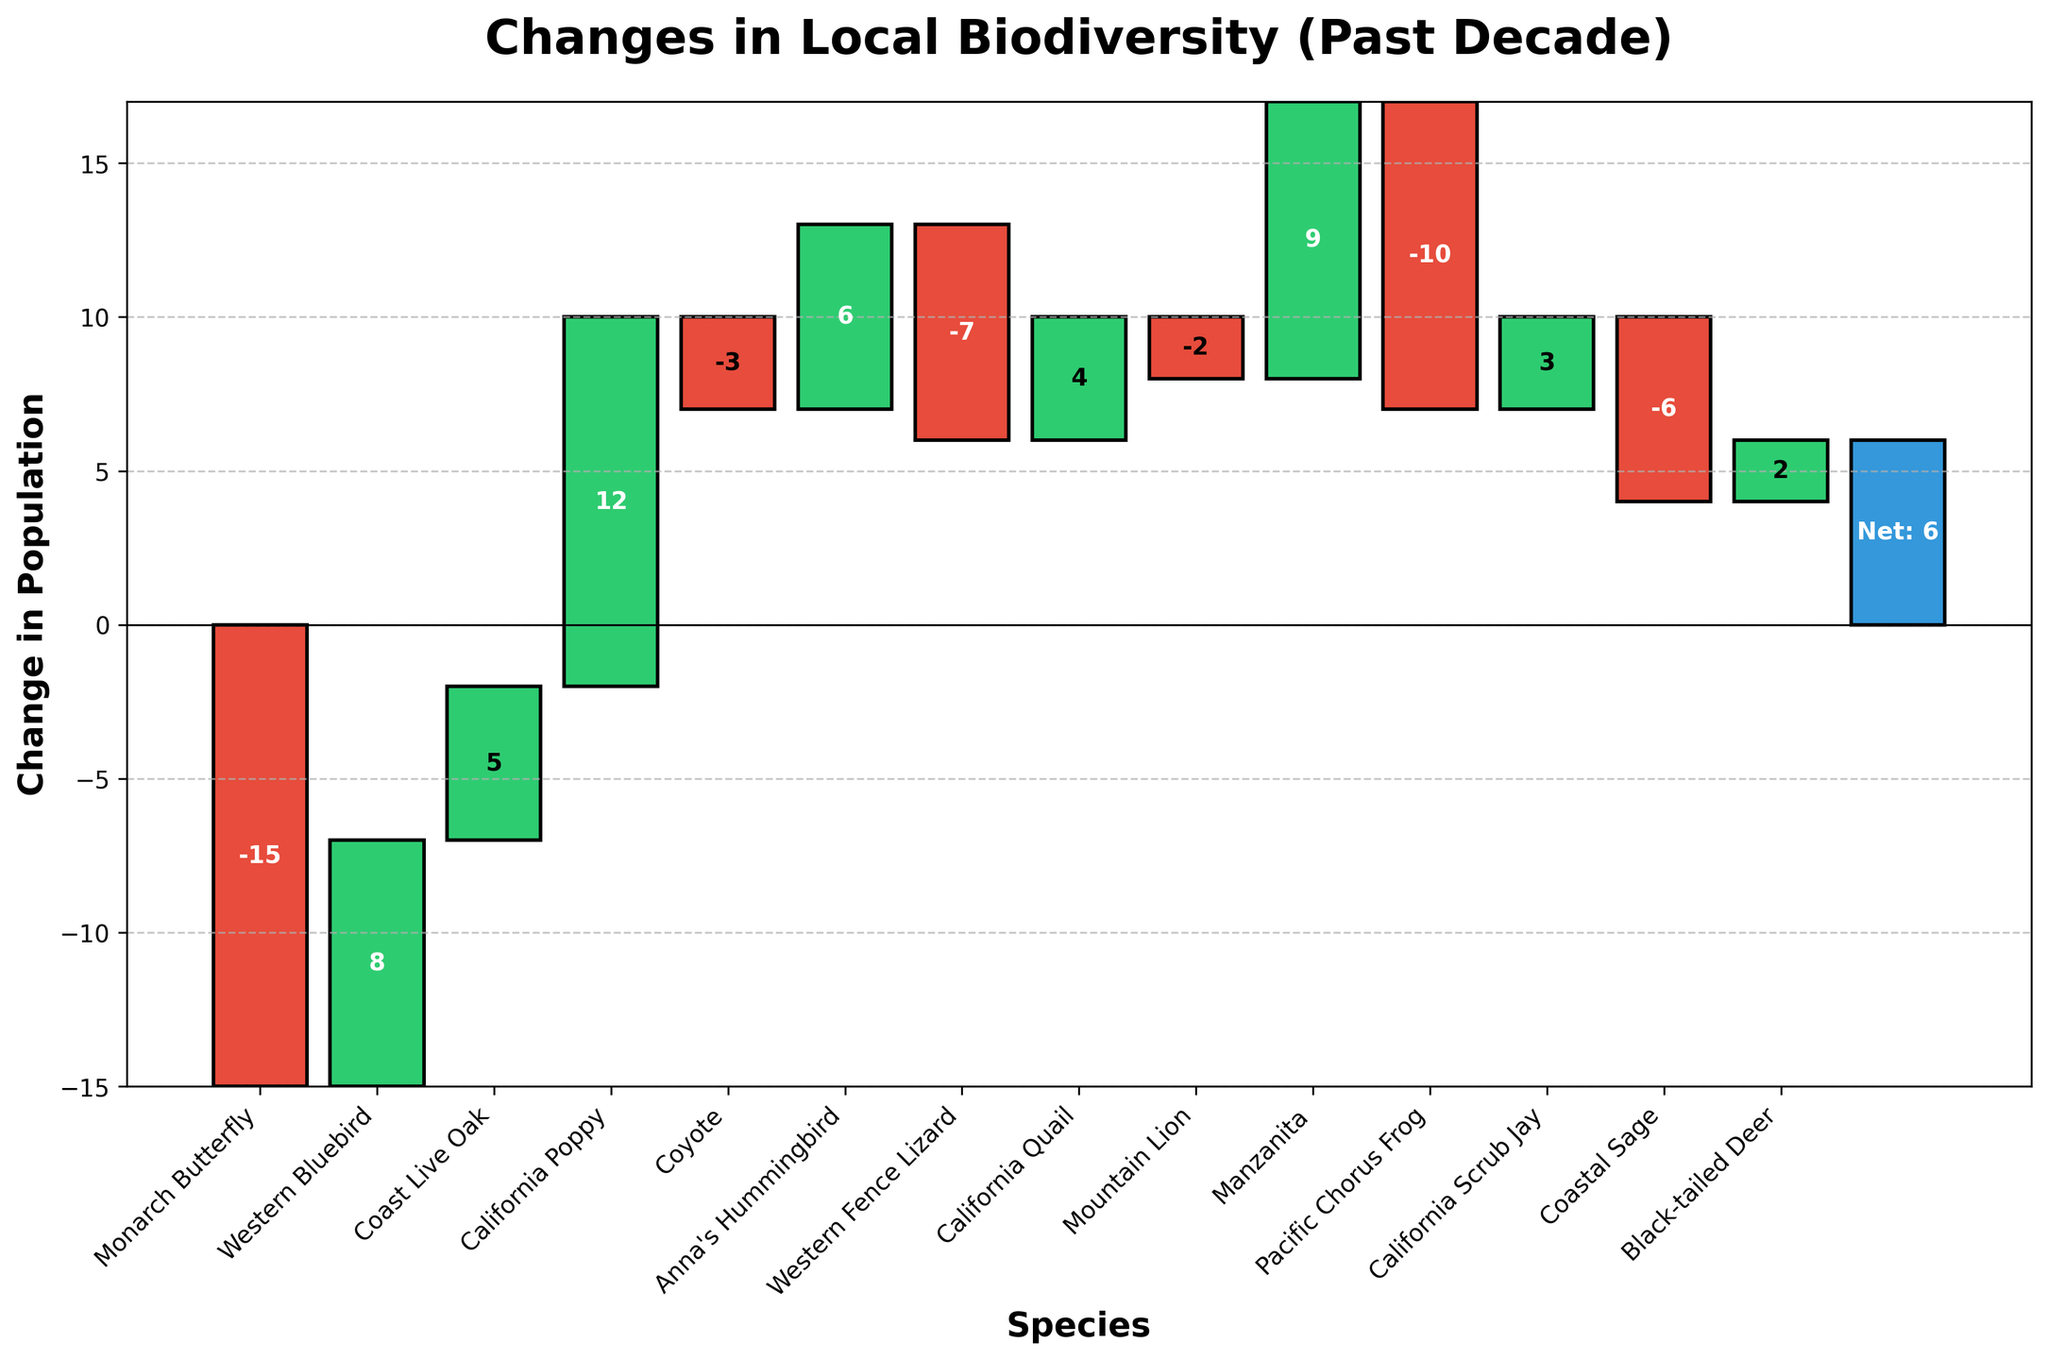What's the overall title of the chart? The overall title of the chart is found at the top and describes the main focus of the chart.
Answer: Changes in Local Biodiversity (Past Decade) How many species showed an increase in population? To determine the number of species that showed an increase in population, count the bars with colors that indicate a positive change.
Answer: 8 Which species had the greatest population decrease? Identify the species with the longest negative bar.
Answer: Monarch Butterfly What is the net change in the total population? The net change is represented by the final bar at the end; it's the cumulative result of all the species' population changes.
Answer: 16 Which species had a higher increase: Manzanita or California Poppy? Compare the lengths of the positive bars for Manzanita and California Poppy.
Answer: California Poppy What is the combined change for the Monarch Butterfly and Western Fence Lizard? Sum the changes for the Monarch Butterfly (-15) and Western Fence Lizard (-7).
Answer: -22 Which had a greater population decrease, the Coyote or the Pacific Chorus Frog? Compare the negative changes for both the Coyote and Pacific Chorus Frog.
Answer: Pacific Chorus Frog How many species experienced a decrease in population? Count the number of species with bars below the zero line.
Answer: 6 What is the cumulative change in population after the California Poppy? Perform cumulative sum up to and including the change for the California Poppy. The cumulative changes are (-15, -7, -2, 10) for Monarch Butterfly, Western Bluebird, Coast Live Oak, and California Poppy respectively.
Answer: 10 What is the difference in population change between Anna's Hummingbird and the Mountain Lion? Subtract the change for Mountain Lion from the change for Anna's Hummingbird.
Answer: 8 